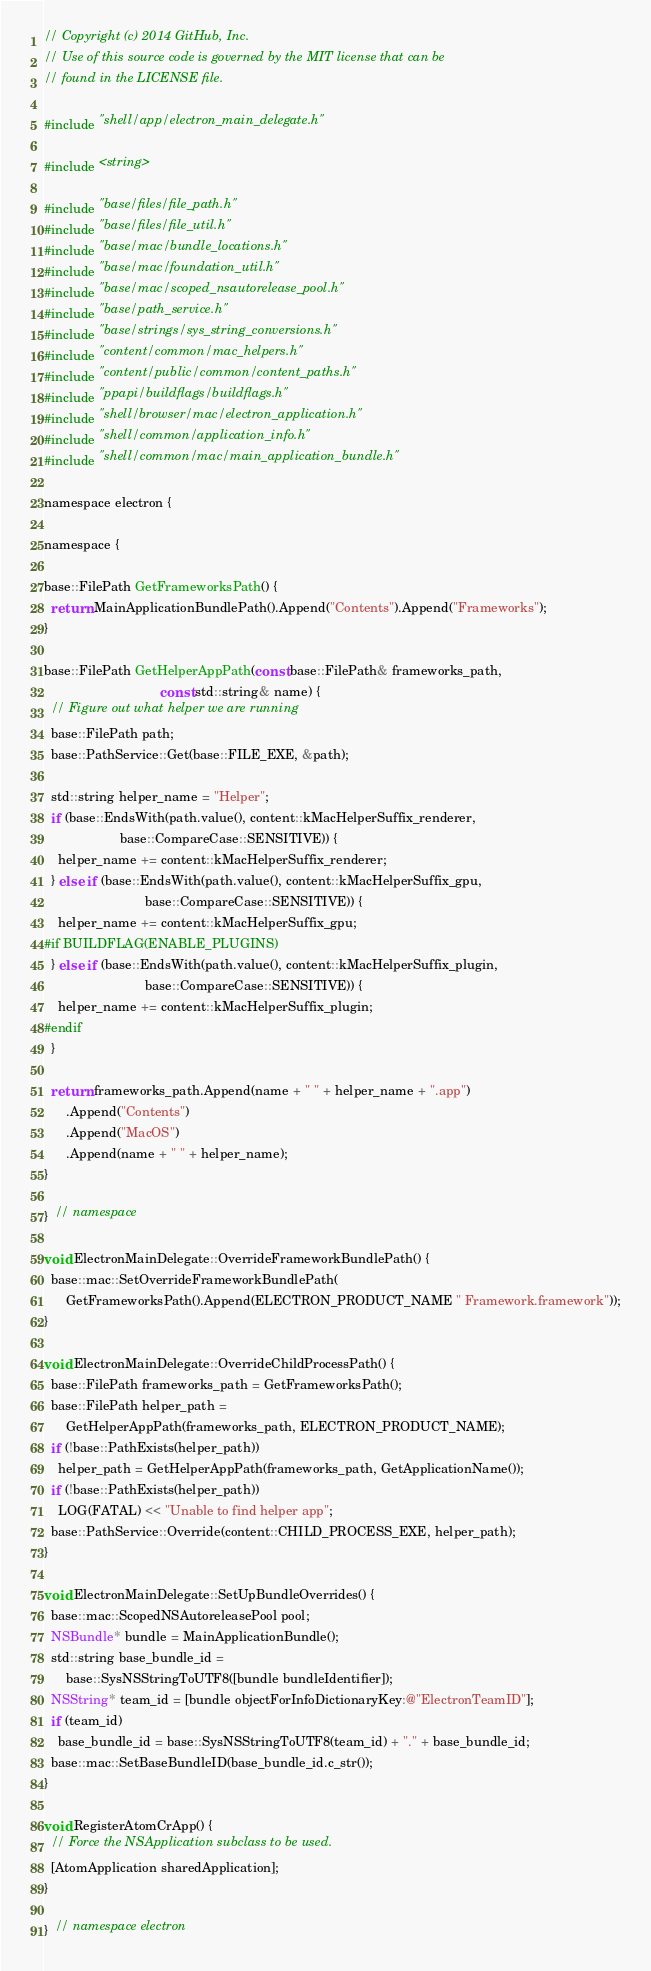<code> <loc_0><loc_0><loc_500><loc_500><_ObjectiveC_>// Copyright (c) 2014 GitHub, Inc.
// Use of this source code is governed by the MIT license that can be
// found in the LICENSE file.

#include "shell/app/electron_main_delegate.h"

#include <string>

#include "base/files/file_path.h"
#include "base/files/file_util.h"
#include "base/mac/bundle_locations.h"
#include "base/mac/foundation_util.h"
#include "base/mac/scoped_nsautorelease_pool.h"
#include "base/path_service.h"
#include "base/strings/sys_string_conversions.h"
#include "content/common/mac_helpers.h"
#include "content/public/common/content_paths.h"
#include "ppapi/buildflags/buildflags.h"
#include "shell/browser/mac/electron_application.h"
#include "shell/common/application_info.h"
#include "shell/common/mac/main_application_bundle.h"

namespace electron {

namespace {

base::FilePath GetFrameworksPath() {
  return MainApplicationBundlePath().Append("Contents").Append("Frameworks");
}

base::FilePath GetHelperAppPath(const base::FilePath& frameworks_path,
                                const std::string& name) {
  // Figure out what helper we are running
  base::FilePath path;
  base::PathService::Get(base::FILE_EXE, &path);

  std::string helper_name = "Helper";
  if (base::EndsWith(path.value(), content::kMacHelperSuffix_renderer,
                     base::CompareCase::SENSITIVE)) {
    helper_name += content::kMacHelperSuffix_renderer;
  } else if (base::EndsWith(path.value(), content::kMacHelperSuffix_gpu,
                            base::CompareCase::SENSITIVE)) {
    helper_name += content::kMacHelperSuffix_gpu;
#if BUILDFLAG(ENABLE_PLUGINS)
  } else if (base::EndsWith(path.value(), content::kMacHelperSuffix_plugin,
                            base::CompareCase::SENSITIVE)) {
    helper_name += content::kMacHelperSuffix_plugin;
#endif
  }

  return frameworks_path.Append(name + " " + helper_name + ".app")
      .Append("Contents")
      .Append("MacOS")
      .Append(name + " " + helper_name);
}

}  // namespace

void ElectronMainDelegate::OverrideFrameworkBundlePath() {
  base::mac::SetOverrideFrameworkBundlePath(
      GetFrameworksPath().Append(ELECTRON_PRODUCT_NAME " Framework.framework"));
}

void ElectronMainDelegate::OverrideChildProcessPath() {
  base::FilePath frameworks_path = GetFrameworksPath();
  base::FilePath helper_path =
      GetHelperAppPath(frameworks_path, ELECTRON_PRODUCT_NAME);
  if (!base::PathExists(helper_path))
    helper_path = GetHelperAppPath(frameworks_path, GetApplicationName());
  if (!base::PathExists(helper_path))
    LOG(FATAL) << "Unable to find helper app";
  base::PathService::Override(content::CHILD_PROCESS_EXE, helper_path);
}

void ElectronMainDelegate::SetUpBundleOverrides() {
  base::mac::ScopedNSAutoreleasePool pool;
  NSBundle* bundle = MainApplicationBundle();
  std::string base_bundle_id =
      base::SysNSStringToUTF8([bundle bundleIdentifier]);
  NSString* team_id = [bundle objectForInfoDictionaryKey:@"ElectronTeamID"];
  if (team_id)
    base_bundle_id = base::SysNSStringToUTF8(team_id) + "." + base_bundle_id;
  base::mac::SetBaseBundleID(base_bundle_id.c_str());
}

void RegisterAtomCrApp() {
  // Force the NSApplication subclass to be used.
  [AtomApplication sharedApplication];
}

}  // namespace electron
</code> 